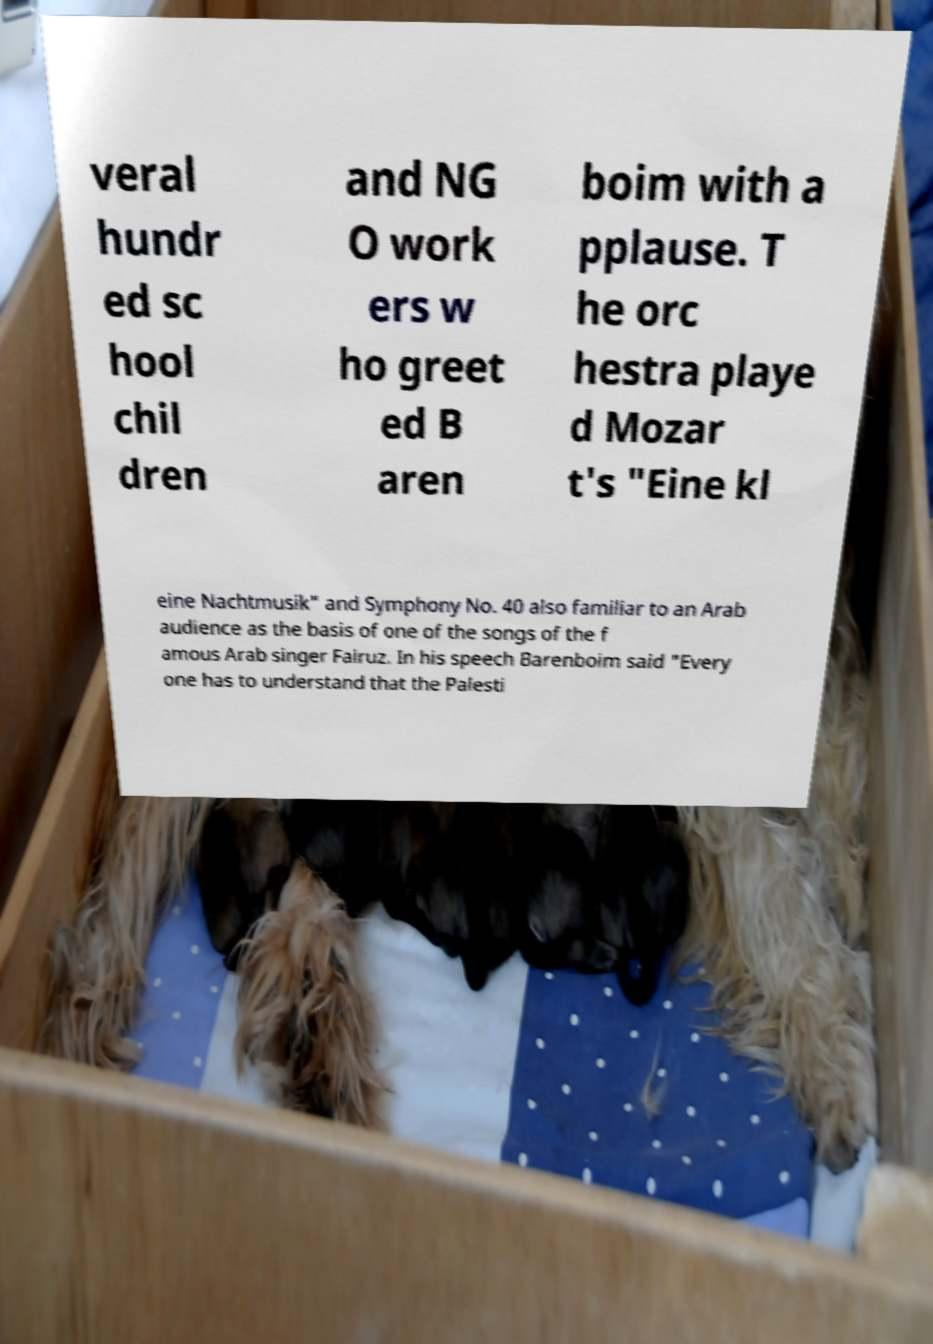Can you accurately transcribe the text from the provided image for me? veral hundr ed sc hool chil dren and NG O work ers w ho greet ed B aren boim with a pplause. T he orc hestra playe d Mozar t's "Eine kl eine Nachtmusik" and Symphony No. 40 also familiar to an Arab audience as the basis of one of the songs of the f amous Arab singer Fairuz. In his speech Barenboim said "Every one has to understand that the Palesti 